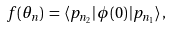<formula> <loc_0><loc_0><loc_500><loc_500>f ( \theta _ { n } ) \, = \, \langle p _ { n _ { 2 } } | \, \phi ( 0 ) \, | p _ { n _ { 1 } } \rangle \, ,</formula> 